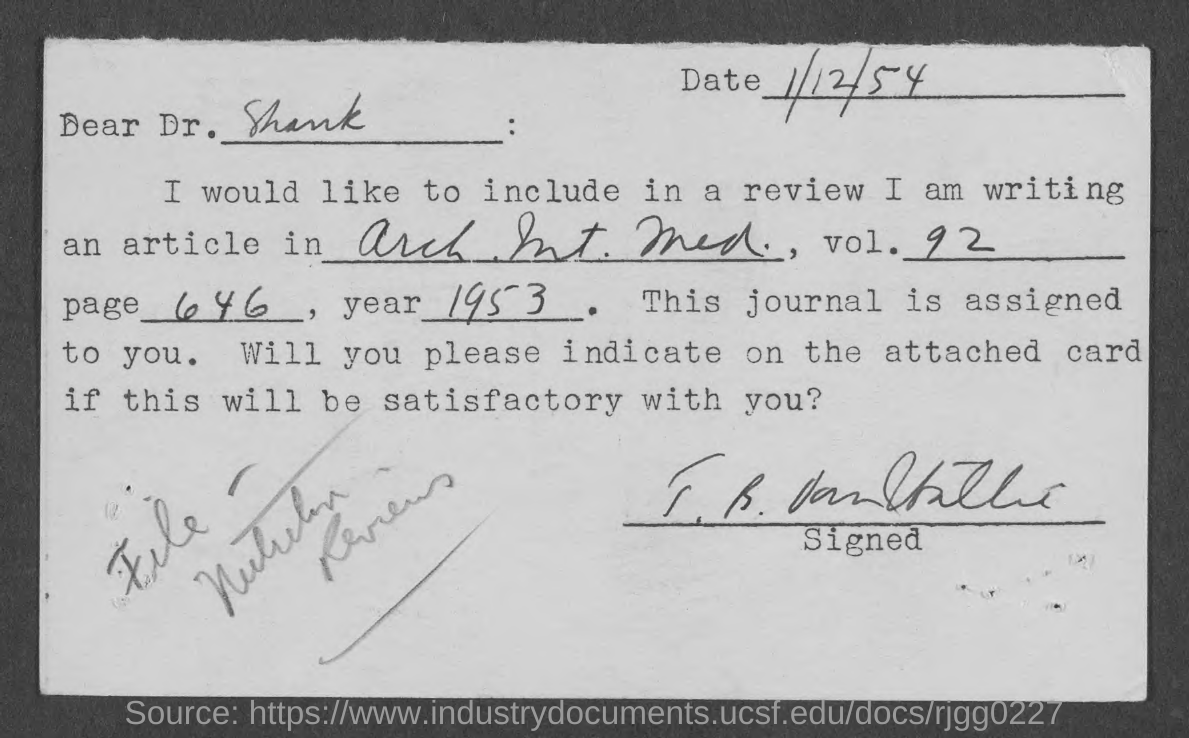Outline some significant characteristics in this image. The letter mentions a "page" number of 646. The article was written in the year 1953. To whom is this letter addressed? Provide the volume number mentioned? 92. Please note that the date mentioned at the top right corner of this letter is 1/12/54. 